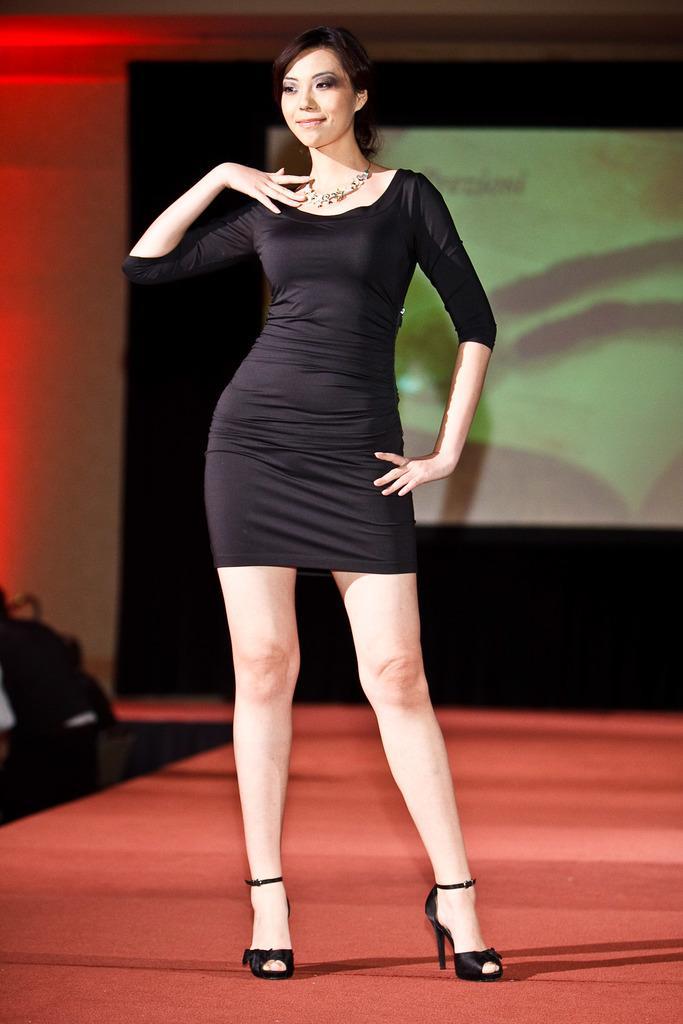In one or two sentences, can you explain what this image depicts? A woman is standing wearing a black dress, necklace and black heels. There is a projector display at the back and a red light at the left back. 